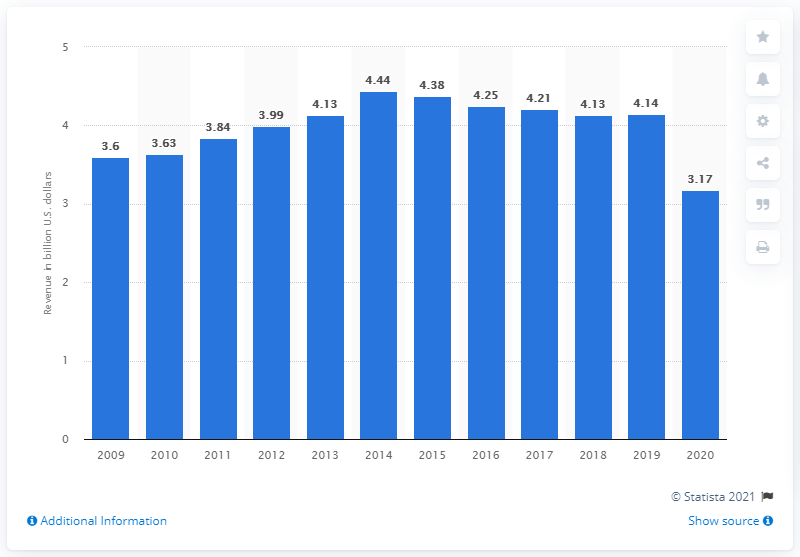Point out several critical features in this image. Bloomin' Brands generated a worldwide revenue of approximately 3.17 in 2020. Bloomin' Brands' revenue in the previous year was approximately 4.14 billion U.S. dollars. 